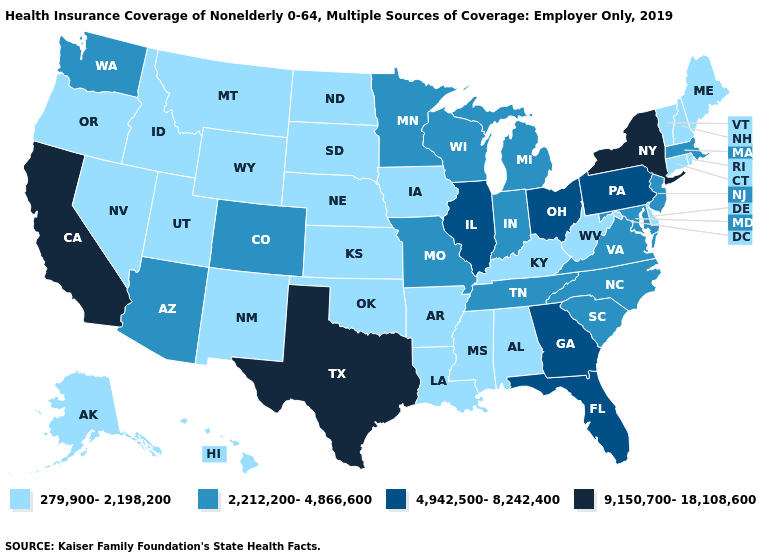What is the highest value in the USA?
Quick response, please. 9,150,700-18,108,600. Name the states that have a value in the range 4,942,500-8,242,400?
Short answer required. Florida, Georgia, Illinois, Ohio, Pennsylvania. What is the value of New Mexico?
Write a very short answer. 279,900-2,198,200. What is the value of Louisiana?
Concise answer only. 279,900-2,198,200. Does Montana have the lowest value in the USA?
Quick response, please. Yes. What is the highest value in the Northeast ?
Write a very short answer. 9,150,700-18,108,600. What is the highest value in the South ?
Keep it brief. 9,150,700-18,108,600. What is the highest value in the MidWest ?
Be succinct. 4,942,500-8,242,400. Does the first symbol in the legend represent the smallest category?
Be succinct. Yes. Among the states that border Minnesota , does Wisconsin have the lowest value?
Write a very short answer. No. Which states have the highest value in the USA?
Be succinct. California, New York, Texas. Does Minnesota have the highest value in the USA?
Quick response, please. No. Name the states that have a value in the range 279,900-2,198,200?
Answer briefly. Alabama, Alaska, Arkansas, Connecticut, Delaware, Hawaii, Idaho, Iowa, Kansas, Kentucky, Louisiana, Maine, Mississippi, Montana, Nebraska, Nevada, New Hampshire, New Mexico, North Dakota, Oklahoma, Oregon, Rhode Island, South Dakota, Utah, Vermont, West Virginia, Wyoming. Does New York have the highest value in the Northeast?
Be succinct. Yes. Name the states that have a value in the range 4,942,500-8,242,400?
Be succinct. Florida, Georgia, Illinois, Ohio, Pennsylvania. 